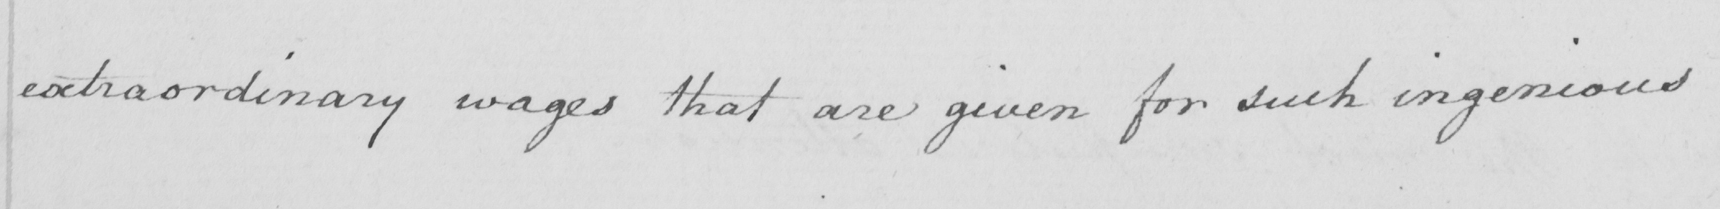What does this handwritten line say? extraordinary wages that are given for such ingenious 